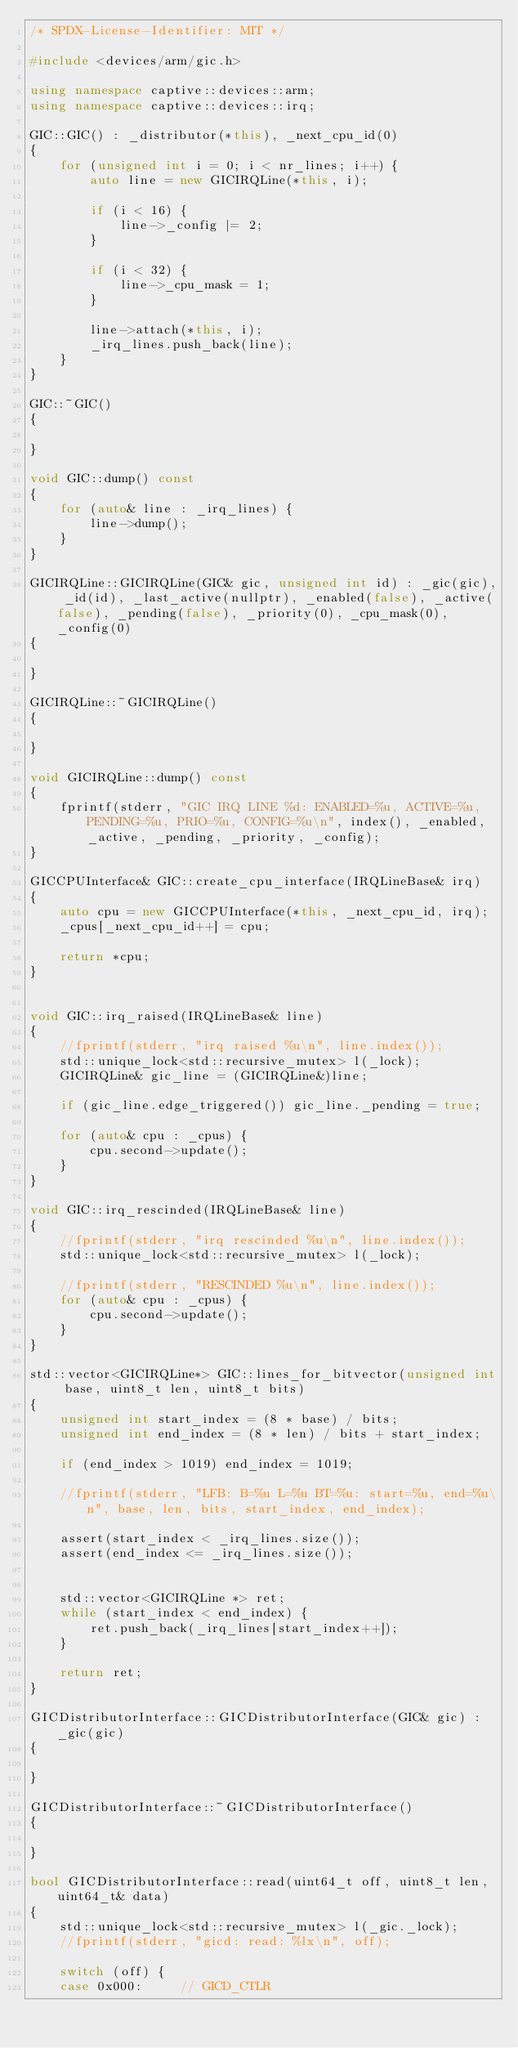Convert code to text. <code><loc_0><loc_0><loc_500><loc_500><_C++_>/* SPDX-License-Identifier: MIT */

#include <devices/arm/gic.h>

using namespace captive::devices::arm;
using namespace captive::devices::irq;

GIC::GIC() : _distributor(*this), _next_cpu_id(0)
{
	for (unsigned int i = 0; i < nr_lines; i++) {
		auto line = new GICIRQLine(*this, i);
		
		if (i < 16) {
			line->_config |= 2;
		}
		
		if (i < 32) {
			line->_cpu_mask = 1;
		}
		
		line->attach(*this, i);
		_irq_lines.push_back(line);
	}
}

GIC::~GIC()
{

}

void GIC::dump() const
{
	for (auto& line : _irq_lines) {
		line->dump();
	}
}

GICIRQLine::GICIRQLine(GIC& gic, unsigned int id) : _gic(gic), _id(id), _last_active(nullptr), _enabled(false), _active(false), _pending(false), _priority(0), _cpu_mask(0), _config(0)
{

}

GICIRQLine::~GICIRQLine()
{

}

void GICIRQLine::dump() const
{
	fprintf(stderr, "GIC IRQ LINE %d: ENABLED=%u, ACTIVE=%u, PENDING=%u, PRIO=%u, CONFIG=%u\n", index(), _enabled, _active, _pending, _priority, _config);
}

GICCPUInterface& GIC::create_cpu_interface(IRQLineBase& irq)
{
	auto cpu = new GICCPUInterface(*this, _next_cpu_id, irq);
	_cpus[_next_cpu_id++] = cpu;
	
	return *cpu;
}


void GIC::irq_raised(IRQLineBase& line)
{
	//fprintf(stderr, "irq raised %u\n", line.index());
	std::unique_lock<std::recursive_mutex> l(_lock);
	GICIRQLine& gic_line = (GICIRQLine&)line;

	if (gic_line.edge_triggered()) gic_line._pending = true;
	
	for (auto& cpu : _cpus) {
		cpu.second->update();
	}
}

void GIC::irq_rescinded(IRQLineBase& line)
{
	//fprintf(stderr, "irq rescinded %u\n", line.index());
	std::unique_lock<std::recursive_mutex> l(_lock);
	
	//fprintf(stderr, "RESCINDED %u\n", line.index());
	for (auto& cpu : _cpus) {
		cpu.second->update();
	}
}

std::vector<GICIRQLine*> GIC::lines_for_bitvector(unsigned int base, uint8_t len, uint8_t bits)
{
	unsigned int start_index = (8 * base) / bits;
	unsigned int end_index = (8 * len) / bits + start_index;
	
	if (end_index > 1019) end_index = 1019;
	
	//fprintf(stderr, "LFB: B=%u L=%u BT=%u: start=%u, end=%u\n", base, len, bits, start_index, end_index);
	
	assert(start_index < _irq_lines.size());
	assert(end_index <= _irq_lines.size());
	
	
	std::vector<GICIRQLine *> ret;
	while (start_index < end_index) {
		ret.push_back(_irq_lines[start_index++]);
	}
	
	return ret;
}

GICDistributorInterface::GICDistributorInterface(GIC& gic) : _gic(gic)
{

}

GICDistributorInterface::~GICDistributorInterface()
{

}

bool GICDistributorInterface::read(uint64_t off, uint8_t len, uint64_t& data)
{
	std::unique_lock<std::recursive_mutex> l(_gic._lock);
	//fprintf(stderr, "gicd: read: %lx\n", off);
	
	switch (off) {
	case 0x000:		// GICD_CTLR</code> 